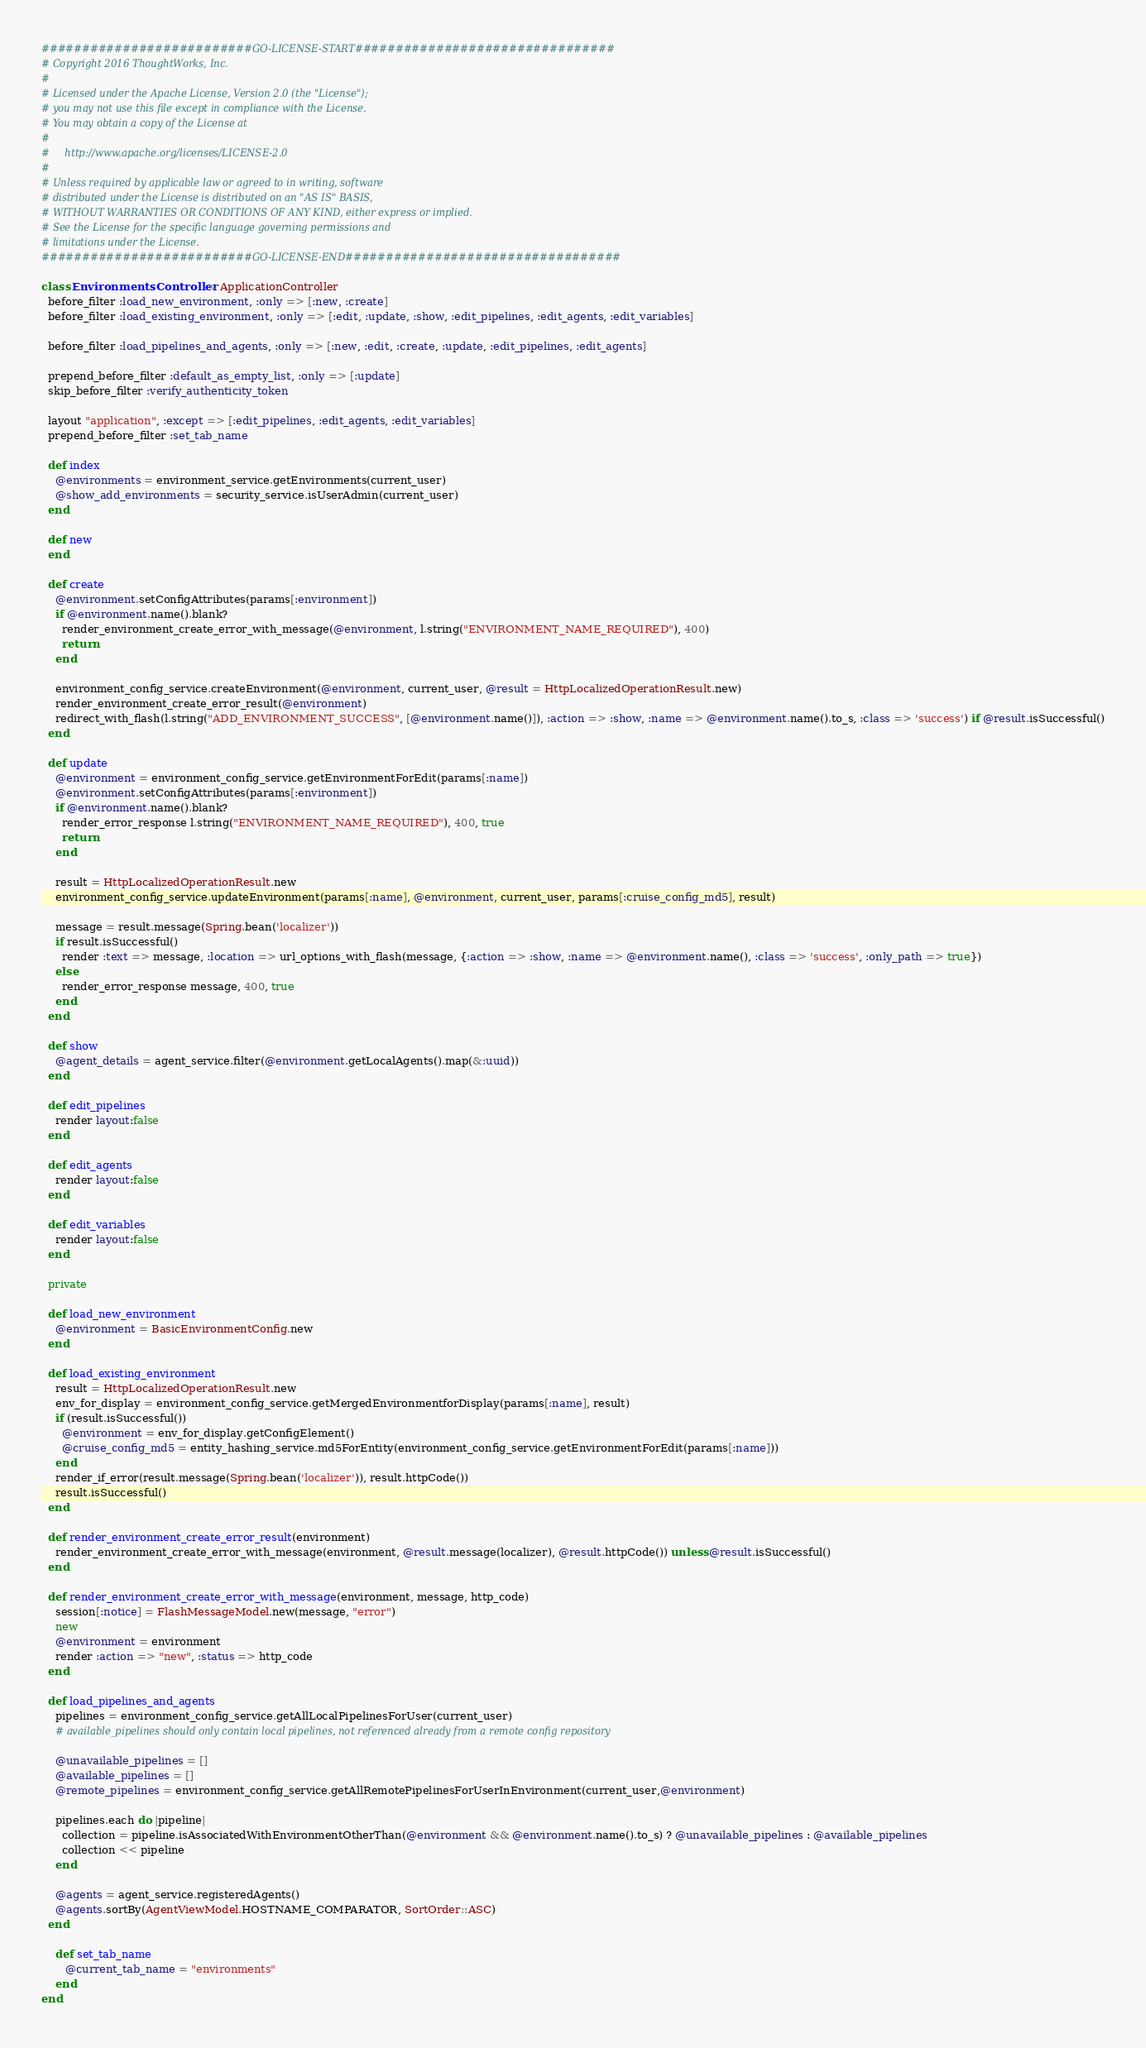Convert code to text. <code><loc_0><loc_0><loc_500><loc_500><_Ruby_>##########################GO-LICENSE-START################################
# Copyright 2016 ThoughtWorks, Inc.
#
# Licensed under the Apache License, Version 2.0 (the "License");
# you may not use this file except in compliance with the License.
# You may obtain a copy of the License at
#
#     http://www.apache.org/licenses/LICENSE-2.0
#
# Unless required by applicable law or agreed to in writing, software
# distributed under the License is distributed on an "AS IS" BASIS,
# WITHOUT WARRANTIES OR CONDITIONS OF ANY KIND, either express or implied.
# See the License for the specific language governing permissions and
# limitations under the License.
##########################GO-LICENSE-END##################################

class EnvironmentsController < ApplicationController
  before_filter :load_new_environment, :only => [:new, :create]
  before_filter :load_existing_environment, :only => [:edit, :update, :show, :edit_pipelines, :edit_agents, :edit_variables]

  before_filter :load_pipelines_and_agents, :only => [:new, :edit, :create, :update, :edit_pipelines, :edit_agents]

  prepend_before_filter :default_as_empty_list, :only => [:update]
  skip_before_filter :verify_authenticity_token

  layout "application", :except => [:edit_pipelines, :edit_agents, :edit_variables]
  prepend_before_filter :set_tab_name

  def index
    @environments = environment_service.getEnvironments(current_user)
    @show_add_environments = security_service.isUserAdmin(current_user)
  end

  def new
  end

  def create
    @environment.setConfigAttributes(params[:environment])
    if @environment.name().blank?
      render_environment_create_error_with_message(@environment, l.string("ENVIRONMENT_NAME_REQUIRED"), 400)
      return
    end

    environment_config_service.createEnvironment(@environment, current_user, @result = HttpLocalizedOperationResult.new)
    render_environment_create_error_result(@environment)
    redirect_with_flash(l.string("ADD_ENVIRONMENT_SUCCESS", [@environment.name()]), :action => :show, :name => @environment.name().to_s, :class => 'success') if @result.isSuccessful()
  end

  def update
    @environment = environment_config_service.getEnvironmentForEdit(params[:name])
    @environment.setConfigAttributes(params[:environment])
    if @environment.name().blank?
      render_error_response l.string("ENVIRONMENT_NAME_REQUIRED"), 400, true
      return
    end

    result = HttpLocalizedOperationResult.new
    environment_config_service.updateEnvironment(params[:name], @environment, current_user, params[:cruise_config_md5], result)

    message = result.message(Spring.bean('localizer'))
    if result.isSuccessful()
      render :text => message, :location => url_options_with_flash(message, {:action => :show, :name => @environment.name(), :class => 'success', :only_path => true})
    else
      render_error_response message, 400, true
    end
  end

  def show
    @agent_details = agent_service.filter(@environment.getLocalAgents().map(&:uuid))
  end

  def edit_pipelines
    render layout:false
  end

  def edit_agents
    render layout:false
  end

  def edit_variables
    render layout:false
  end

  private

  def load_new_environment
    @environment = BasicEnvironmentConfig.new
  end

  def load_existing_environment
    result = HttpLocalizedOperationResult.new
    env_for_display = environment_config_service.getMergedEnvironmentforDisplay(params[:name], result)
    if (result.isSuccessful())
      @environment = env_for_display.getConfigElement()
      @cruise_config_md5 = entity_hashing_service.md5ForEntity(environment_config_service.getEnvironmentForEdit(params[:name]))
    end
    render_if_error(result.message(Spring.bean('localizer')), result.httpCode())
    result.isSuccessful()
  end

  def render_environment_create_error_result(environment)
    render_environment_create_error_with_message(environment, @result.message(localizer), @result.httpCode()) unless @result.isSuccessful()
  end

  def render_environment_create_error_with_message(environment, message, http_code)
    session[:notice] = FlashMessageModel.new(message, "error")
    new
    @environment = environment
    render :action => "new", :status => http_code
  end

  def load_pipelines_and_agents
    pipelines = environment_config_service.getAllLocalPipelinesForUser(current_user)
    # available_pipelines should only contain local pipelines, not referenced already from a remote config repository

    @unavailable_pipelines = []
    @available_pipelines = []
    @remote_pipelines = environment_config_service.getAllRemotePipelinesForUserInEnvironment(current_user,@environment)

    pipelines.each do |pipeline|
      collection = pipeline.isAssociatedWithEnvironmentOtherThan(@environment && @environment.name().to_s) ? @unavailable_pipelines : @available_pipelines
      collection << pipeline
    end

    @agents = agent_service.registeredAgents()
    @agents.sortBy(AgentViewModel.HOSTNAME_COMPARATOR, SortOrder::ASC)
  end

    def set_tab_name
       @current_tab_name = "environments"
    end
end
</code> 